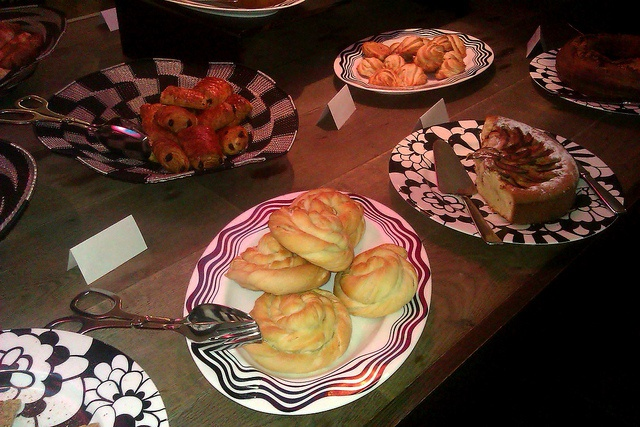Describe the objects in this image and their specific colors. I can see dining table in black, maroon, tan, and lightgray tones, bowl in black, maroon, and brown tones, cake in black, maroon, and brown tones, donut in black, tan, khaki, and orange tones, and donut in black, tan, red, and salmon tones in this image. 